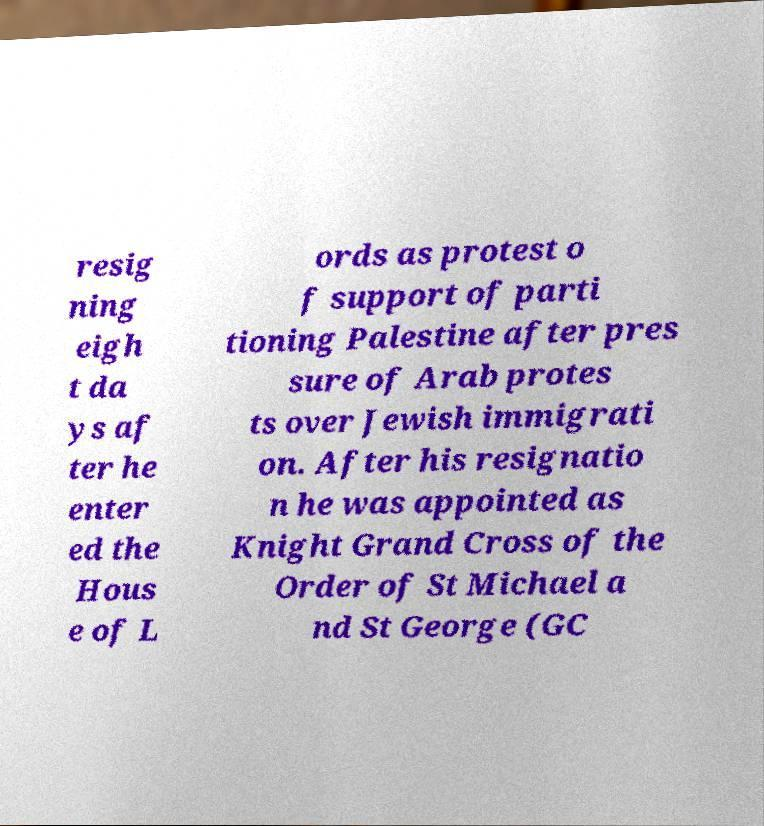What messages or text are displayed in this image? I need them in a readable, typed format. resig ning eigh t da ys af ter he enter ed the Hous e of L ords as protest o f support of parti tioning Palestine after pres sure of Arab protes ts over Jewish immigrati on. After his resignatio n he was appointed as Knight Grand Cross of the Order of St Michael a nd St George (GC 